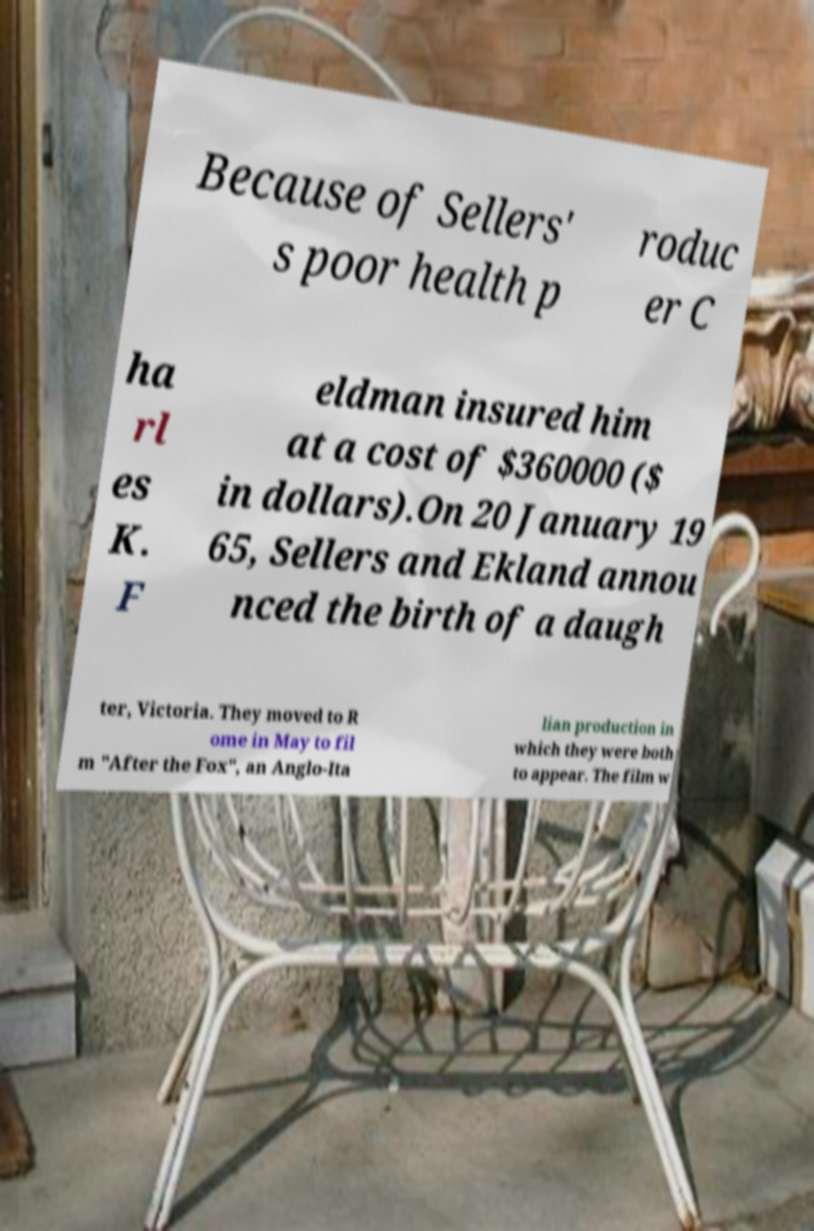I need the written content from this picture converted into text. Can you do that? Because of Sellers' s poor health p roduc er C ha rl es K. F eldman insured him at a cost of $360000 ($ in dollars).On 20 January 19 65, Sellers and Ekland annou nced the birth of a daugh ter, Victoria. They moved to R ome in May to fil m "After the Fox", an Anglo-Ita lian production in which they were both to appear. The film w 